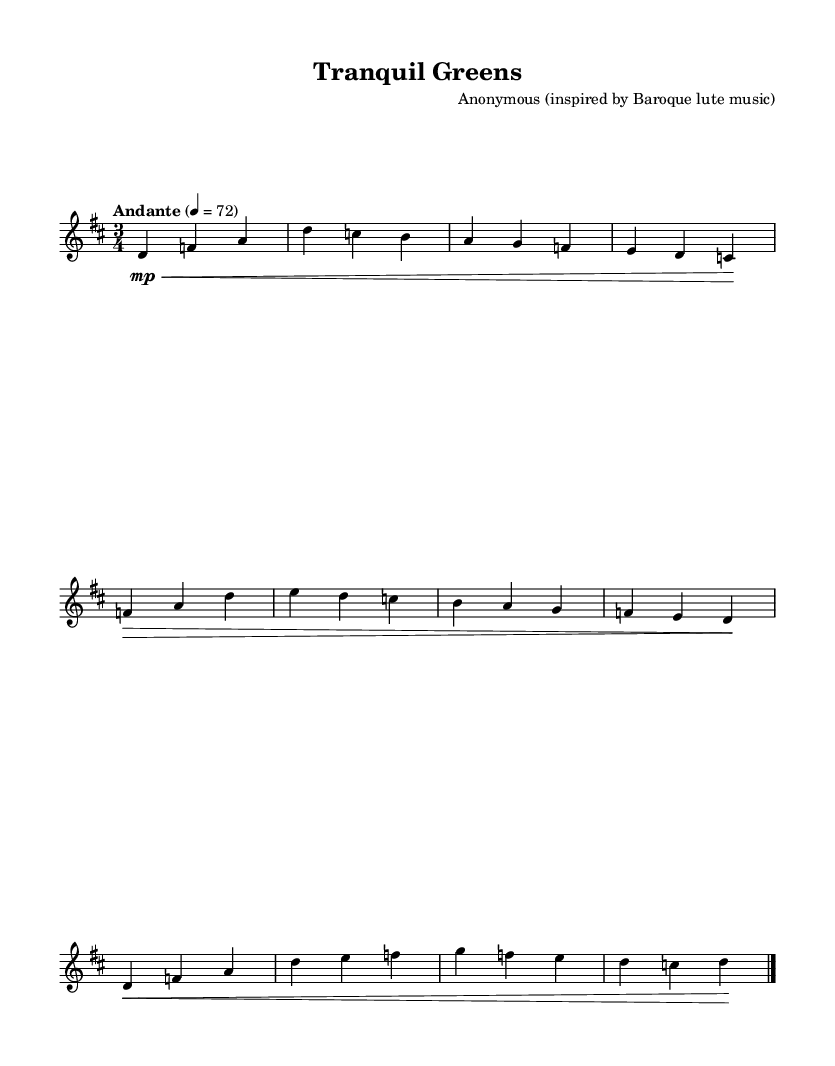What is the key signature of this music? The key signature is D major, which has two sharps (F# and C#). This can be confirmed by identifying the key signature placed at the beginning of the staff.
Answer: D major What is the time signature of the piece? The time signature is 3/4, indicated by the two numbers (3 and 4) placed at the beginning of the music. The upper number '3' tells us there are three beats in each measure, and the lower number '4' indicates that the quarter note gets one beat.
Answer: 3/4 What tempo marking is specified for this composition? The tempo marking given is "Andante," which indicates a moderate walking pace. It is noted alongside the metronome marking of quarter note equals 72, suggesting that each quarter note should be played at this speed.
Answer: Andante How many sections are there in this piece? The piece features three sections: Section A, Section B, and Section A prime (A'). Section A is repeated in A', showing the structure typical of many Baroque compositions, indicating the importance of repetition.
Answer: Three What dynamic markings are present in the piece? The piece contains both mezzo-piano (mp) and forte (>) markings. The 'mp' is shown at the beginning of Section A, suggesting a soft dynamic, while the '>' indicates a strong dynamic for the beginning of Section B, emphasizing the expressive contrasts common in Baroque music.
Answer: mezzo-piano and forte 